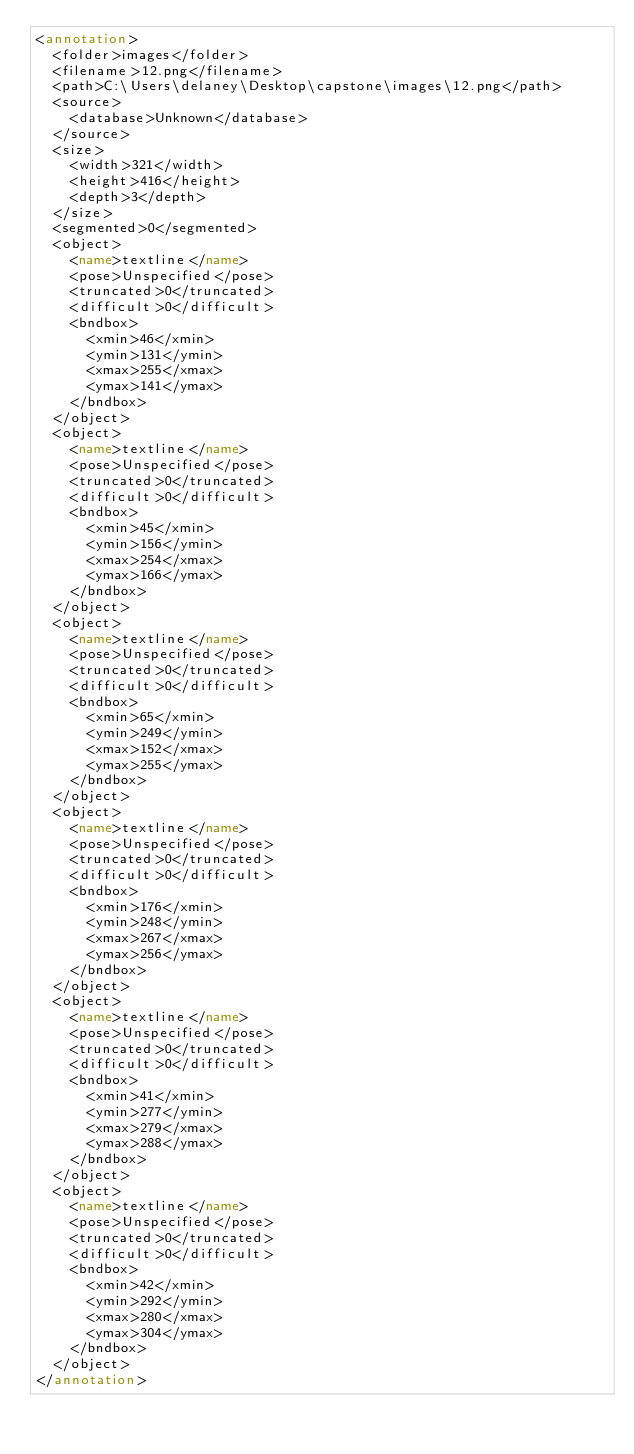Convert code to text. <code><loc_0><loc_0><loc_500><loc_500><_XML_><annotation>
	<folder>images</folder>
	<filename>12.png</filename>
	<path>C:\Users\delaney\Desktop\capstone\images\12.png</path>
	<source>
		<database>Unknown</database>
	</source>
	<size>
		<width>321</width>
		<height>416</height>
		<depth>3</depth>
	</size>
	<segmented>0</segmented>
	<object>
		<name>textline</name>
		<pose>Unspecified</pose>
		<truncated>0</truncated>
		<difficult>0</difficult>
		<bndbox>
			<xmin>46</xmin>
			<ymin>131</ymin>
			<xmax>255</xmax>
			<ymax>141</ymax>
		</bndbox>
	</object>
	<object>
		<name>textline</name>
		<pose>Unspecified</pose>
		<truncated>0</truncated>
		<difficult>0</difficult>
		<bndbox>
			<xmin>45</xmin>
			<ymin>156</ymin>
			<xmax>254</xmax>
			<ymax>166</ymax>
		</bndbox>
	</object>
	<object>
		<name>textline</name>
		<pose>Unspecified</pose>
		<truncated>0</truncated>
		<difficult>0</difficult>
		<bndbox>
			<xmin>65</xmin>
			<ymin>249</ymin>
			<xmax>152</xmax>
			<ymax>255</ymax>
		</bndbox>
	</object>
	<object>
		<name>textline</name>
		<pose>Unspecified</pose>
		<truncated>0</truncated>
		<difficult>0</difficult>
		<bndbox>
			<xmin>176</xmin>
			<ymin>248</ymin>
			<xmax>267</xmax>
			<ymax>256</ymax>
		</bndbox>
	</object>
	<object>
		<name>textline</name>
		<pose>Unspecified</pose>
		<truncated>0</truncated>
		<difficult>0</difficult>
		<bndbox>
			<xmin>41</xmin>
			<ymin>277</ymin>
			<xmax>279</xmax>
			<ymax>288</ymax>
		</bndbox>
	</object>
	<object>
		<name>textline</name>
		<pose>Unspecified</pose>
		<truncated>0</truncated>
		<difficult>0</difficult>
		<bndbox>
			<xmin>42</xmin>
			<ymin>292</ymin>
			<xmax>280</xmax>
			<ymax>304</ymax>
		</bndbox>
	</object>
</annotation></code> 